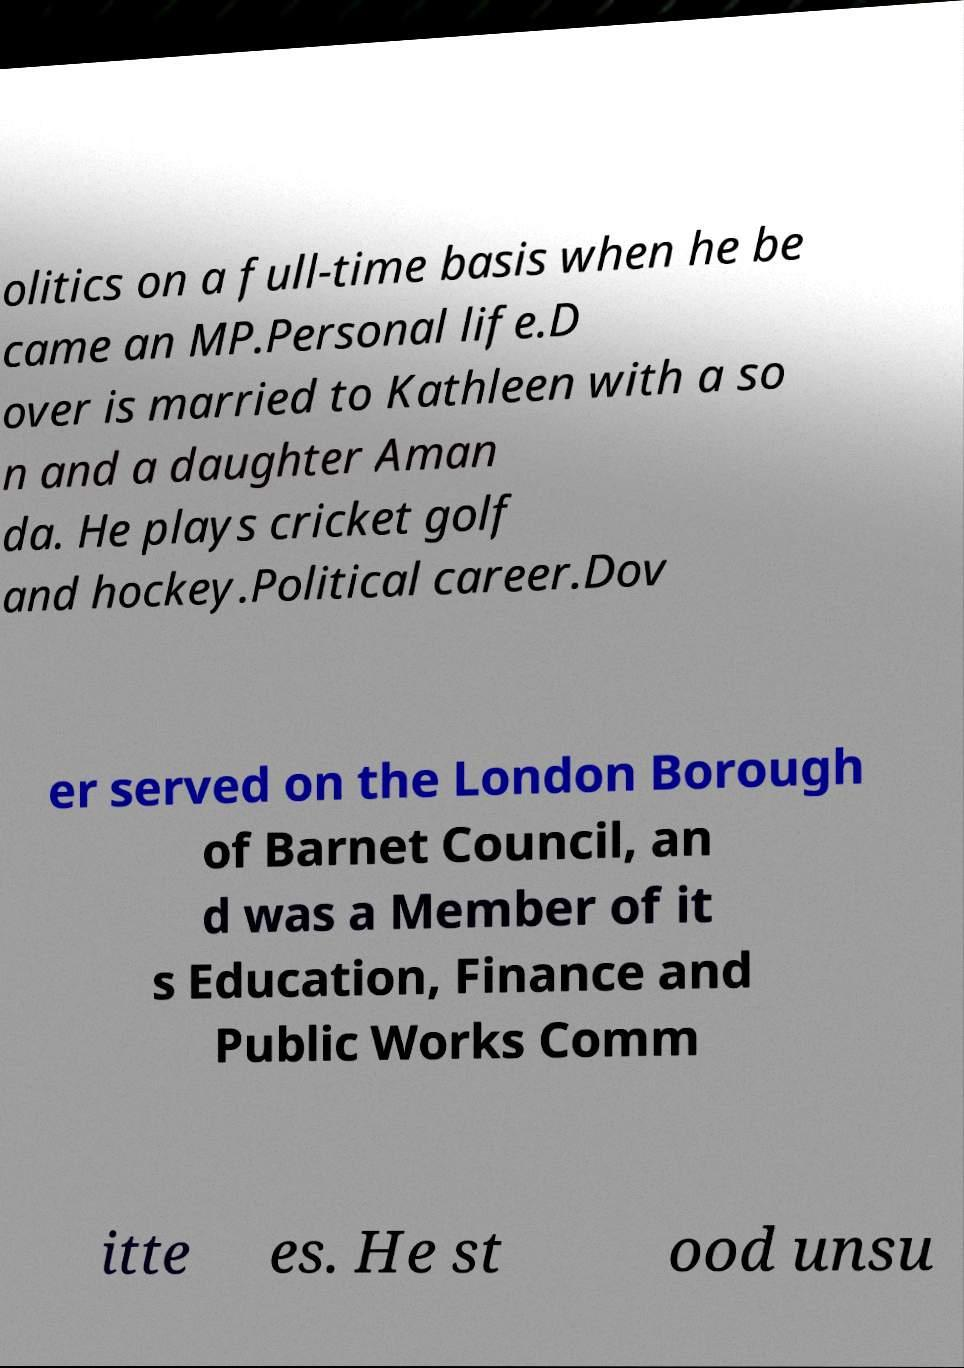Could you extract and type out the text from this image? olitics on a full-time basis when he be came an MP.Personal life.D over is married to Kathleen with a so n and a daughter Aman da. He plays cricket golf and hockey.Political career.Dov er served on the London Borough of Barnet Council, an d was a Member of it s Education, Finance and Public Works Comm itte es. He st ood unsu 